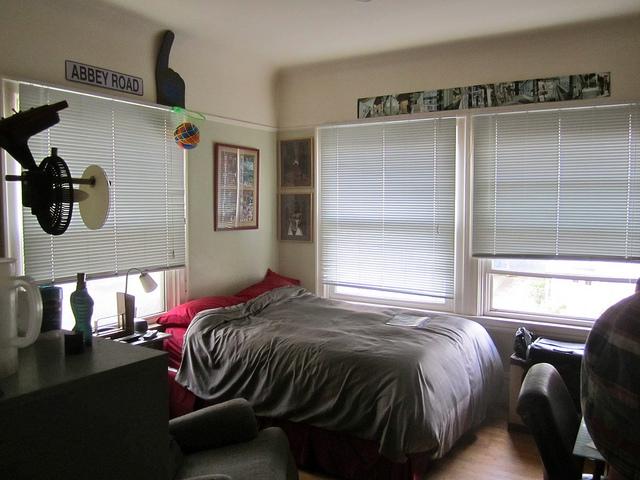Where is the Abbey Road sign?
Short answer required. Wall. Is the bed made in this photo?
Keep it brief. Yes. What is this place called?
Write a very short answer. Bedroom. 